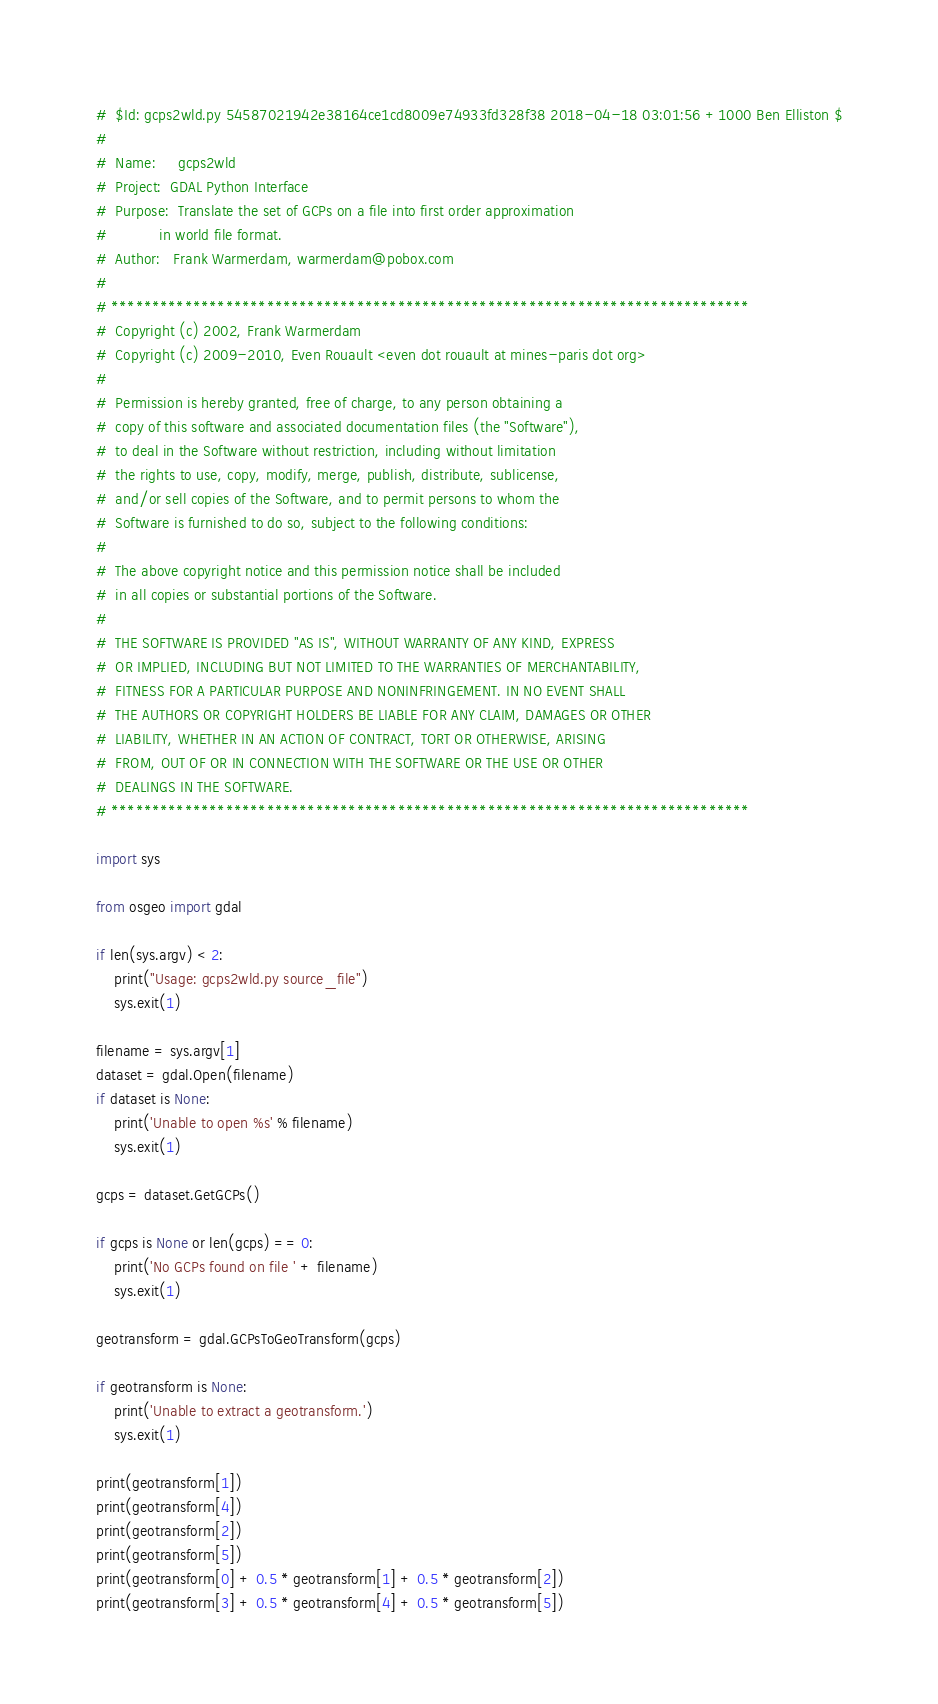Convert code to text. <code><loc_0><loc_0><loc_500><loc_500><_Python_>#  $Id: gcps2wld.py 54587021942e38164ce1cd8009e74933fd328f38 2018-04-18 03:01:56 +1000 Ben Elliston $
#
#  Name:     gcps2wld
#  Project:  GDAL Python Interface
#  Purpose:  Translate the set of GCPs on a file into first order approximation
#            in world file format.
#  Author:   Frank Warmerdam, warmerdam@pobox.com
#
# ******************************************************************************
#  Copyright (c) 2002, Frank Warmerdam
#  Copyright (c) 2009-2010, Even Rouault <even dot rouault at mines-paris dot org>
#
#  Permission is hereby granted, free of charge, to any person obtaining a
#  copy of this software and associated documentation files (the "Software"),
#  to deal in the Software without restriction, including without limitation
#  the rights to use, copy, modify, merge, publish, distribute, sublicense,
#  and/or sell copies of the Software, and to permit persons to whom the
#  Software is furnished to do so, subject to the following conditions:
#
#  The above copyright notice and this permission notice shall be included
#  in all copies or substantial portions of the Software.
#
#  THE SOFTWARE IS PROVIDED "AS IS", WITHOUT WARRANTY OF ANY KIND, EXPRESS
#  OR IMPLIED, INCLUDING BUT NOT LIMITED TO THE WARRANTIES OF MERCHANTABILITY,
#  FITNESS FOR A PARTICULAR PURPOSE AND NONINFRINGEMENT. IN NO EVENT SHALL
#  THE AUTHORS OR COPYRIGHT HOLDERS BE LIABLE FOR ANY CLAIM, DAMAGES OR OTHER
#  LIABILITY, WHETHER IN AN ACTION OF CONTRACT, TORT OR OTHERWISE, ARISING
#  FROM, OUT OF OR IN CONNECTION WITH THE SOFTWARE OR THE USE OR OTHER
#  DEALINGS IN THE SOFTWARE.
# ******************************************************************************

import sys

from osgeo import gdal

if len(sys.argv) < 2:
    print("Usage: gcps2wld.py source_file")
    sys.exit(1)

filename = sys.argv[1]
dataset = gdal.Open(filename)
if dataset is None:
    print('Unable to open %s' % filename)
    sys.exit(1)

gcps = dataset.GetGCPs()

if gcps is None or len(gcps) == 0:
    print('No GCPs found on file ' + filename)
    sys.exit(1)

geotransform = gdal.GCPsToGeoTransform(gcps)

if geotransform is None:
    print('Unable to extract a geotransform.')
    sys.exit(1)

print(geotransform[1])
print(geotransform[4])
print(geotransform[2])
print(geotransform[5])
print(geotransform[0] + 0.5 * geotransform[1] + 0.5 * geotransform[2])
print(geotransform[3] + 0.5 * geotransform[4] + 0.5 * geotransform[5])
</code> 